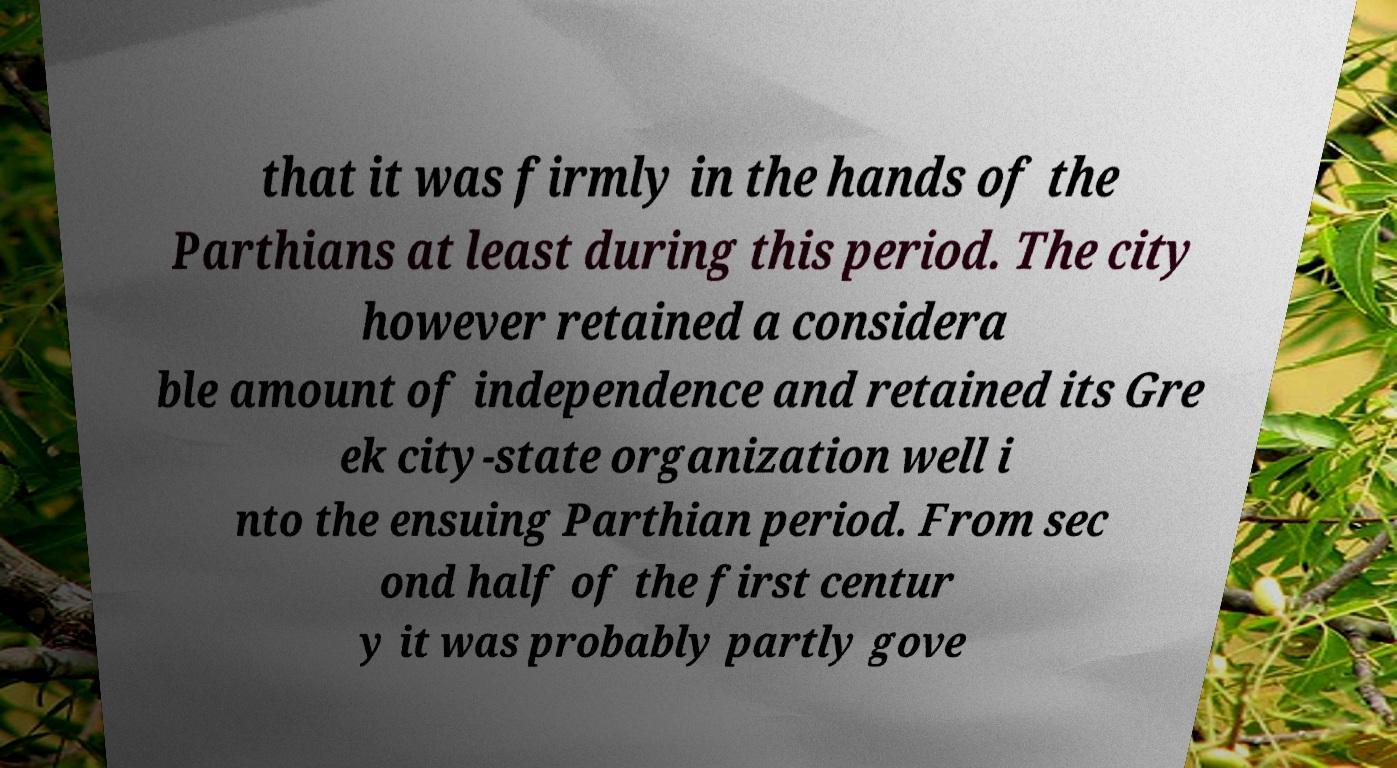Please identify and transcribe the text found in this image. that it was firmly in the hands of the Parthians at least during this period. The city however retained a considera ble amount of independence and retained its Gre ek city-state organization well i nto the ensuing Parthian period. From sec ond half of the first centur y it was probably partly gove 